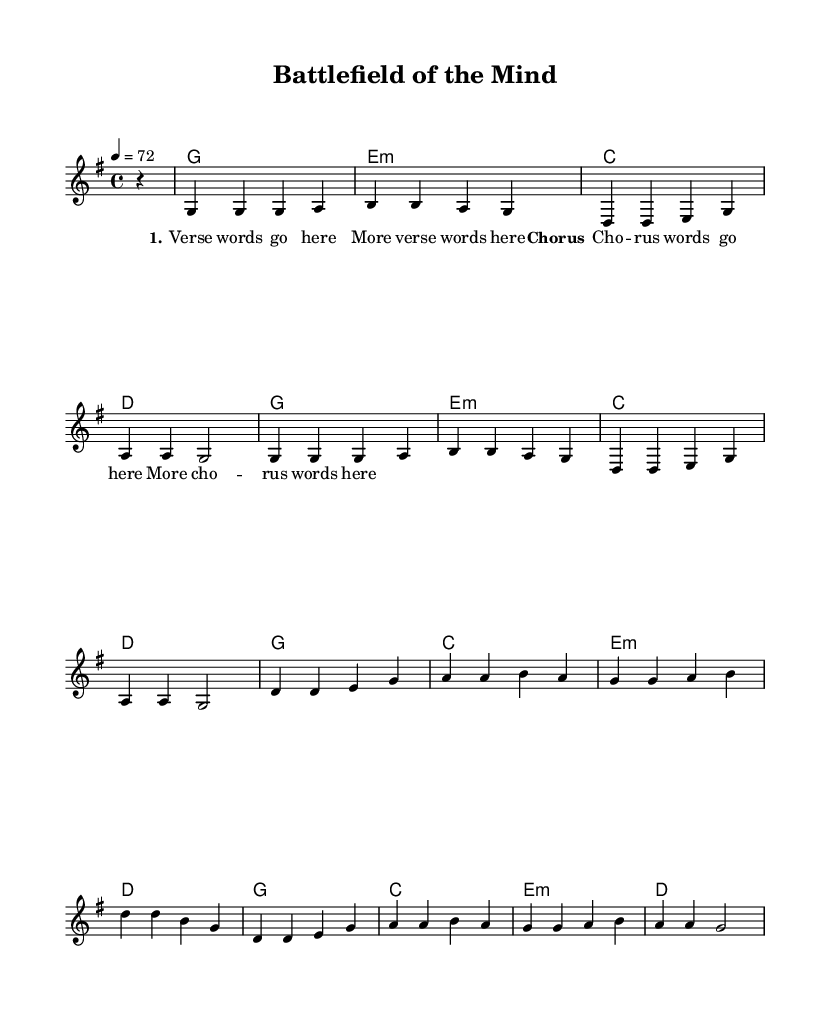What is the key signature of this music? The key signature is G major, which has one sharp (F#). It is indicated at the beginning of the staff.
Answer: G major What is the time signature of this music? The time signature is 4/4, which means there are four beats in each measure. This is also shown at the beginning of the staff after the key signature.
Answer: 4/4 What is the tempo marking for the piece? The tempo marking is quarter note equals 72, which defines the speed at which the music should be played. It appears above the staff at the beginning.
Answer: 72 How many measures are in this melody section? The melody consists of 12 measures in total, as indicated by the grouping of notes and rests throughout the section.
Answer: 12 What is the harmonic function of the final chord in the progression? The final chord is D major, which serves as the tonic in the key of G major, providing a resolution to the harmony. This can be inferred from its position and function in the chord sequence.
Answer: Tonic What is the structure of the lyrics in this song? The lyrics include a verse followed by a chorus, which is a common structure in country music. The verse words are presented first, followed by the chorus words, giving a clear storytelling element.
Answer: Verse and Chorus 